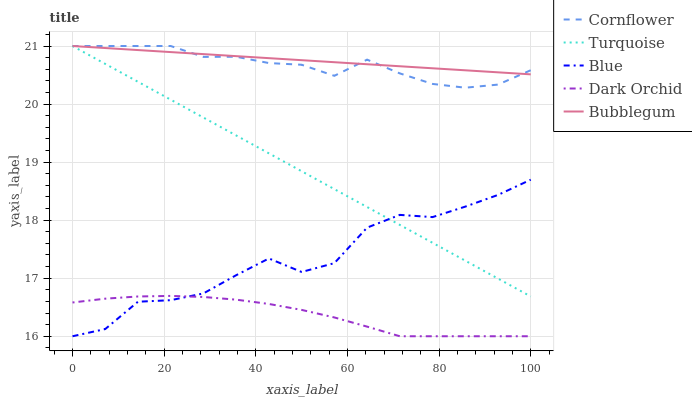Does Dark Orchid have the minimum area under the curve?
Answer yes or no. Yes. Does Bubblegum have the maximum area under the curve?
Answer yes or no. Yes. Does Cornflower have the minimum area under the curve?
Answer yes or no. No. Does Cornflower have the maximum area under the curve?
Answer yes or no. No. Is Bubblegum the smoothest?
Answer yes or no. Yes. Is Blue the roughest?
Answer yes or no. Yes. Is Cornflower the smoothest?
Answer yes or no. No. Is Cornflower the roughest?
Answer yes or no. No. Does Cornflower have the lowest value?
Answer yes or no. No. Does Bubblegum have the highest value?
Answer yes or no. Yes. Does Dark Orchid have the highest value?
Answer yes or no. No. Is Blue less than Bubblegum?
Answer yes or no. Yes. Is Turquoise greater than Dark Orchid?
Answer yes or no. Yes. Does Blue intersect Bubblegum?
Answer yes or no. No. 